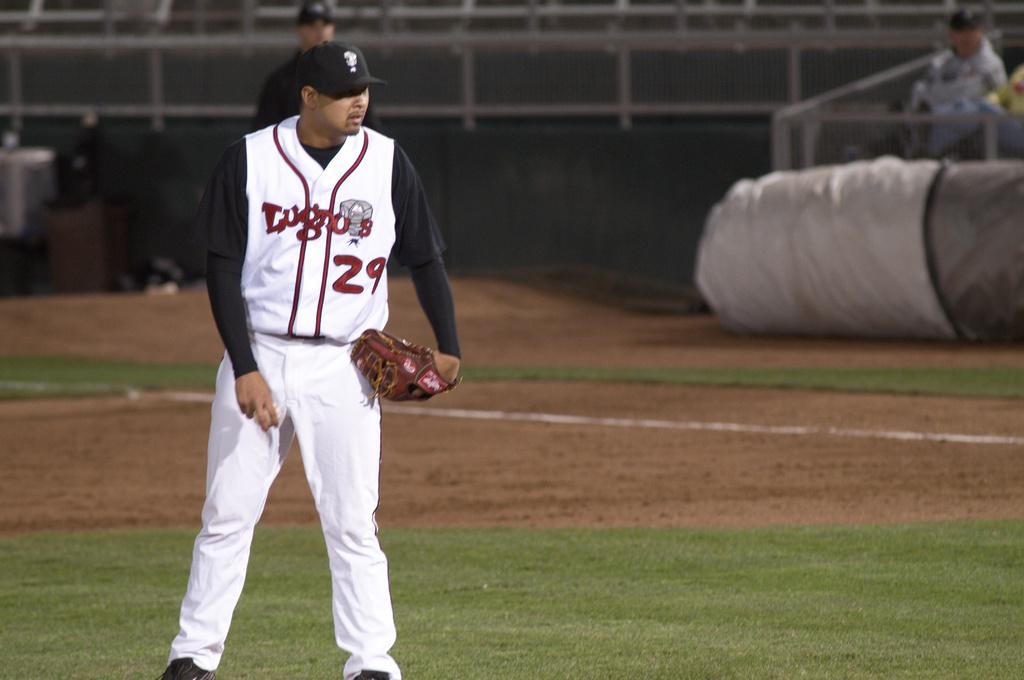What is the player's number?
Your response must be concise. 29. What is word above the number 29 on the player's shirt?
Ensure brevity in your answer.  Lugnos. 